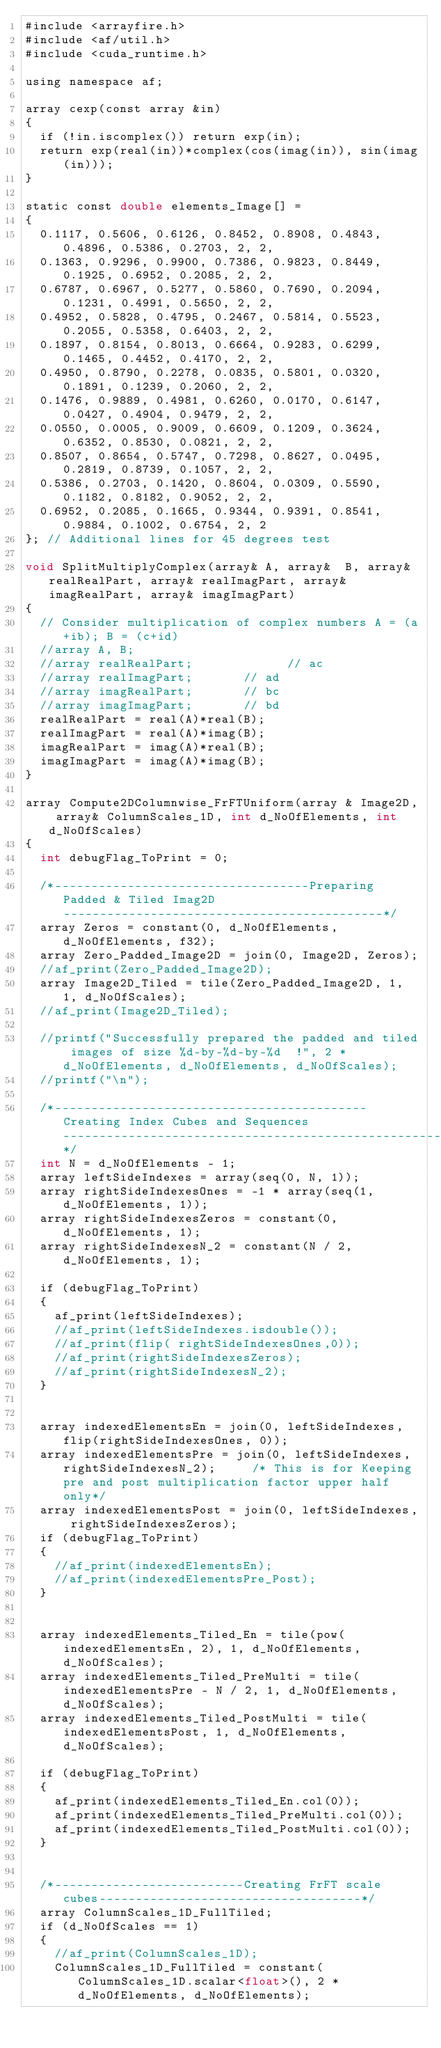Convert code to text. <code><loc_0><loc_0><loc_500><loc_500><_Cuda_>#include <arrayfire.h>
#include <af/util.h>
#include <cuda_runtime.h>

using namespace af;

array cexp(const array &in)
{
	if (!in.iscomplex()) return exp(in);
	return exp(real(in))*complex(cos(imag(in)), sin(imag(in)));
}

static const double elements_Image[] =
{
	0.1117, 0.5606, 0.6126, 0.8452, 0.8908, 0.4843, 0.4896, 0.5386, 0.2703, 2, 2,
	0.1363, 0.9296, 0.9900, 0.7386, 0.9823, 0.8449, 0.1925, 0.6952, 0.2085, 2, 2,
	0.6787, 0.6967, 0.5277, 0.5860, 0.7690, 0.2094, 0.1231, 0.4991, 0.5650, 2, 2,
	0.4952, 0.5828, 0.4795, 0.2467, 0.5814, 0.5523, 0.2055, 0.5358, 0.6403, 2, 2,
	0.1897, 0.8154, 0.8013, 0.6664, 0.9283, 0.6299, 0.1465, 0.4452, 0.4170, 2, 2,
	0.4950, 0.8790, 0.2278, 0.0835, 0.5801, 0.0320, 0.1891, 0.1239, 0.2060, 2, 2,
	0.1476, 0.9889, 0.4981, 0.6260, 0.0170, 0.6147, 0.0427, 0.4904, 0.9479, 2, 2,
	0.0550, 0.0005, 0.9009, 0.6609, 0.1209, 0.3624, 0.6352, 0.8530, 0.0821, 2, 2,
	0.8507, 0.8654, 0.5747, 0.7298, 0.8627, 0.0495, 0.2819, 0.8739, 0.1057, 2, 2,
	0.5386, 0.2703, 0.1420, 0.8604, 0.0309, 0.5590, 0.1182, 0.8182, 0.9052, 2, 2,
	0.6952, 0.2085, 0.1665, 0.9344, 0.9391, 0.8541, 0.9884, 0.1002, 0.6754, 2, 2
}; // Additional lines for 45 degrees test

void SplitMultiplyComplex(array& A, array&  B, array& realRealPart, array& realImagPart, array& imagRealPart, array& imagImagPart)
{
	// Consider multiplication of complex numbers A = (a+ib); B = (c+id)	
	//array A, B;
	//array realRealPart;             // ac
	//array realImagPart;				// ad
	//array imagRealPart;				// bc
	//array imagImagPart;				// bd
	realRealPart = real(A)*real(B);
	realImagPart = real(A)*imag(B);
	imagRealPart = imag(A)*real(B);
	imagImagPart = imag(A)*imag(B);
}

array Compute2DColumnwise_FrFTUniform(array & Image2D, array& ColumnScales_1D, int d_NoOfElements, int d_NoOfScales)
{
	int debugFlag_ToPrint = 0;
	
	/*-----------------------------------Preparing Padded & Tiled Imag2D --------------------------------------------*/
	array Zeros = constant(0, d_NoOfElements, d_NoOfElements, f32);
	array Zero_Padded_Image2D = join(0, Image2D, Zeros);
	//af_print(Zero_Padded_Image2D);
	array Image2D_Tiled = tile(Zero_Padded_Image2D, 1, 1, d_NoOfScales);
	//af_print(Image2D_Tiled);

	//printf("Successfully prepared the padded and tiled images of size %d-by-%d-by-%d  !", 2 * d_NoOfElements, d_NoOfElements, d_NoOfScales);
	//printf("\n");

	/*-------------------------------------------Creating Index Cubes and Sequences----------------------------------------------------*/
	int N = d_NoOfElements - 1;
	array leftSideIndexes = array(seq(0, N, 1));
	array rightSideIndexesOnes = -1 * array(seq(1, d_NoOfElements, 1));
	array rightSideIndexesZeros = constant(0, d_NoOfElements, 1);
	array rightSideIndexesN_2 = constant(N / 2, d_NoOfElements, 1);

	if (debugFlag_ToPrint)
	{
		af_print(leftSideIndexes);
		//af_print(leftSideIndexes.isdouble());
		//af_print(flip( rightSideIndexesOnes,0));
		//af_print(rightSideIndexesZeros);
		//af_print(rightSideIndexesN_2);
	}


	array indexedElementsEn = join(0, leftSideIndexes, flip(rightSideIndexesOnes, 0));
	array indexedElementsPre = join(0, leftSideIndexes, rightSideIndexesN_2);     /* This is for Keeping pre and post multiplication factor upper half only*/
	array indexedElementsPost = join(0, leftSideIndexes, rightSideIndexesZeros);
	if (debugFlag_ToPrint)
	{
		//af_print(indexedElementsEn);
		//af_print(indexedElementsPre_Post);
	}


	array indexedElements_Tiled_En = tile(pow(indexedElementsEn, 2), 1, d_NoOfElements, d_NoOfScales);
	array indexedElements_Tiled_PreMulti = tile(indexedElementsPre - N / 2, 1, d_NoOfElements, d_NoOfScales);
	array indexedElements_Tiled_PostMulti = tile(indexedElementsPost, 1, d_NoOfElements, d_NoOfScales);
	
	if (debugFlag_ToPrint)
	{
		af_print(indexedElements_Tiled_En.col(0));
		af_print(indexedElements_Tiled_PreMulti.col(0));
		af_print(indexedElements_Tiled_PostMulti.col(0));
	}


	/*--------------------------Creating FrFT scale cubes------------------------------------*/
	array ColumnScales_1D_FullTiled;
	if (d_NoOfScales == 1)
	{
		//af_print(ColumnScales_1D);
		ColumnScales_1D_FullTiled = constant(ColumnScales_1D.scalar<float>(), 2 * d_NoOfElements, d_NoOfElements);</code> 